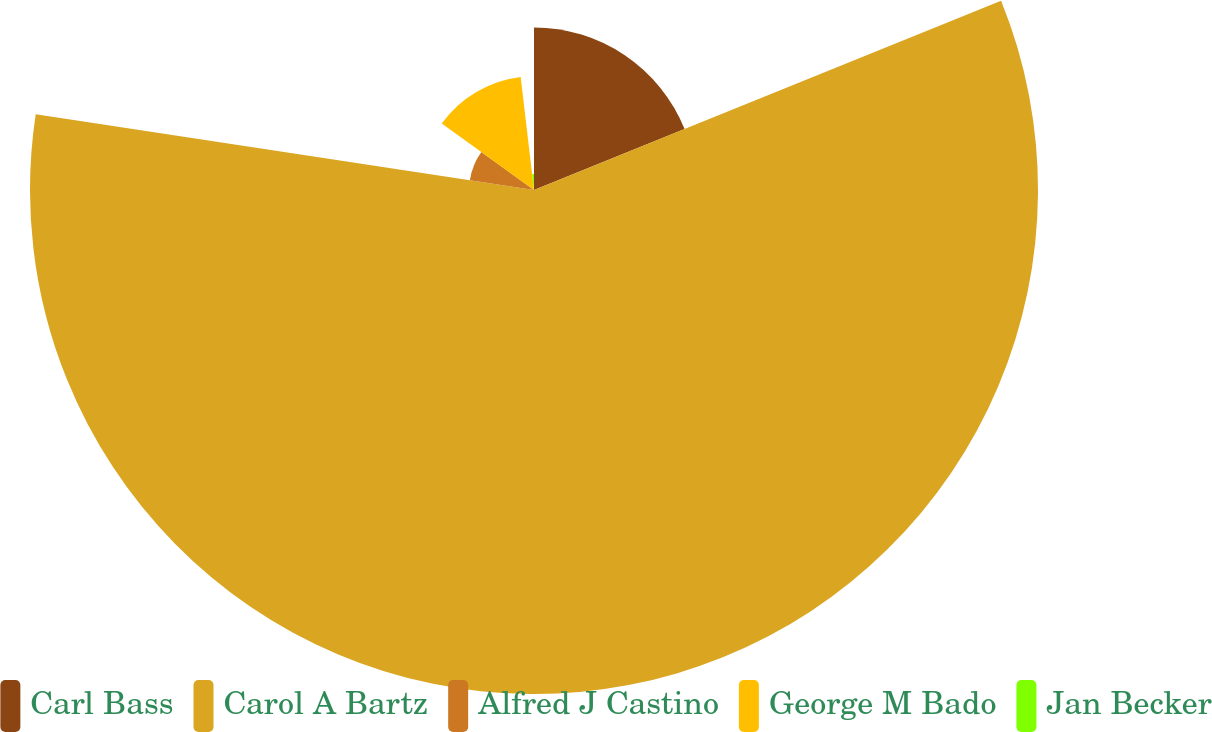<chart> <loc_0><loc_0><loc_500><loc_500><pie_chart><fcel>Carl Bass<fcel>Carol A Bartz<fcel>Alfred J Castino<fcel>George M Bado<fcel>Jan Becker<nl><fcel>18.87%<fcel>58.53%<fcel>7.53%<fcel>13.2%<fcel>1.87%<nl></chart> 